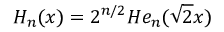<formula> <loc_0><loc_0><loc_500><loc_500>H _ { n } ( x ) = 2 ^ { n / 2 } H e _ { n } ( \sqrt { 2 } x )</formula> 